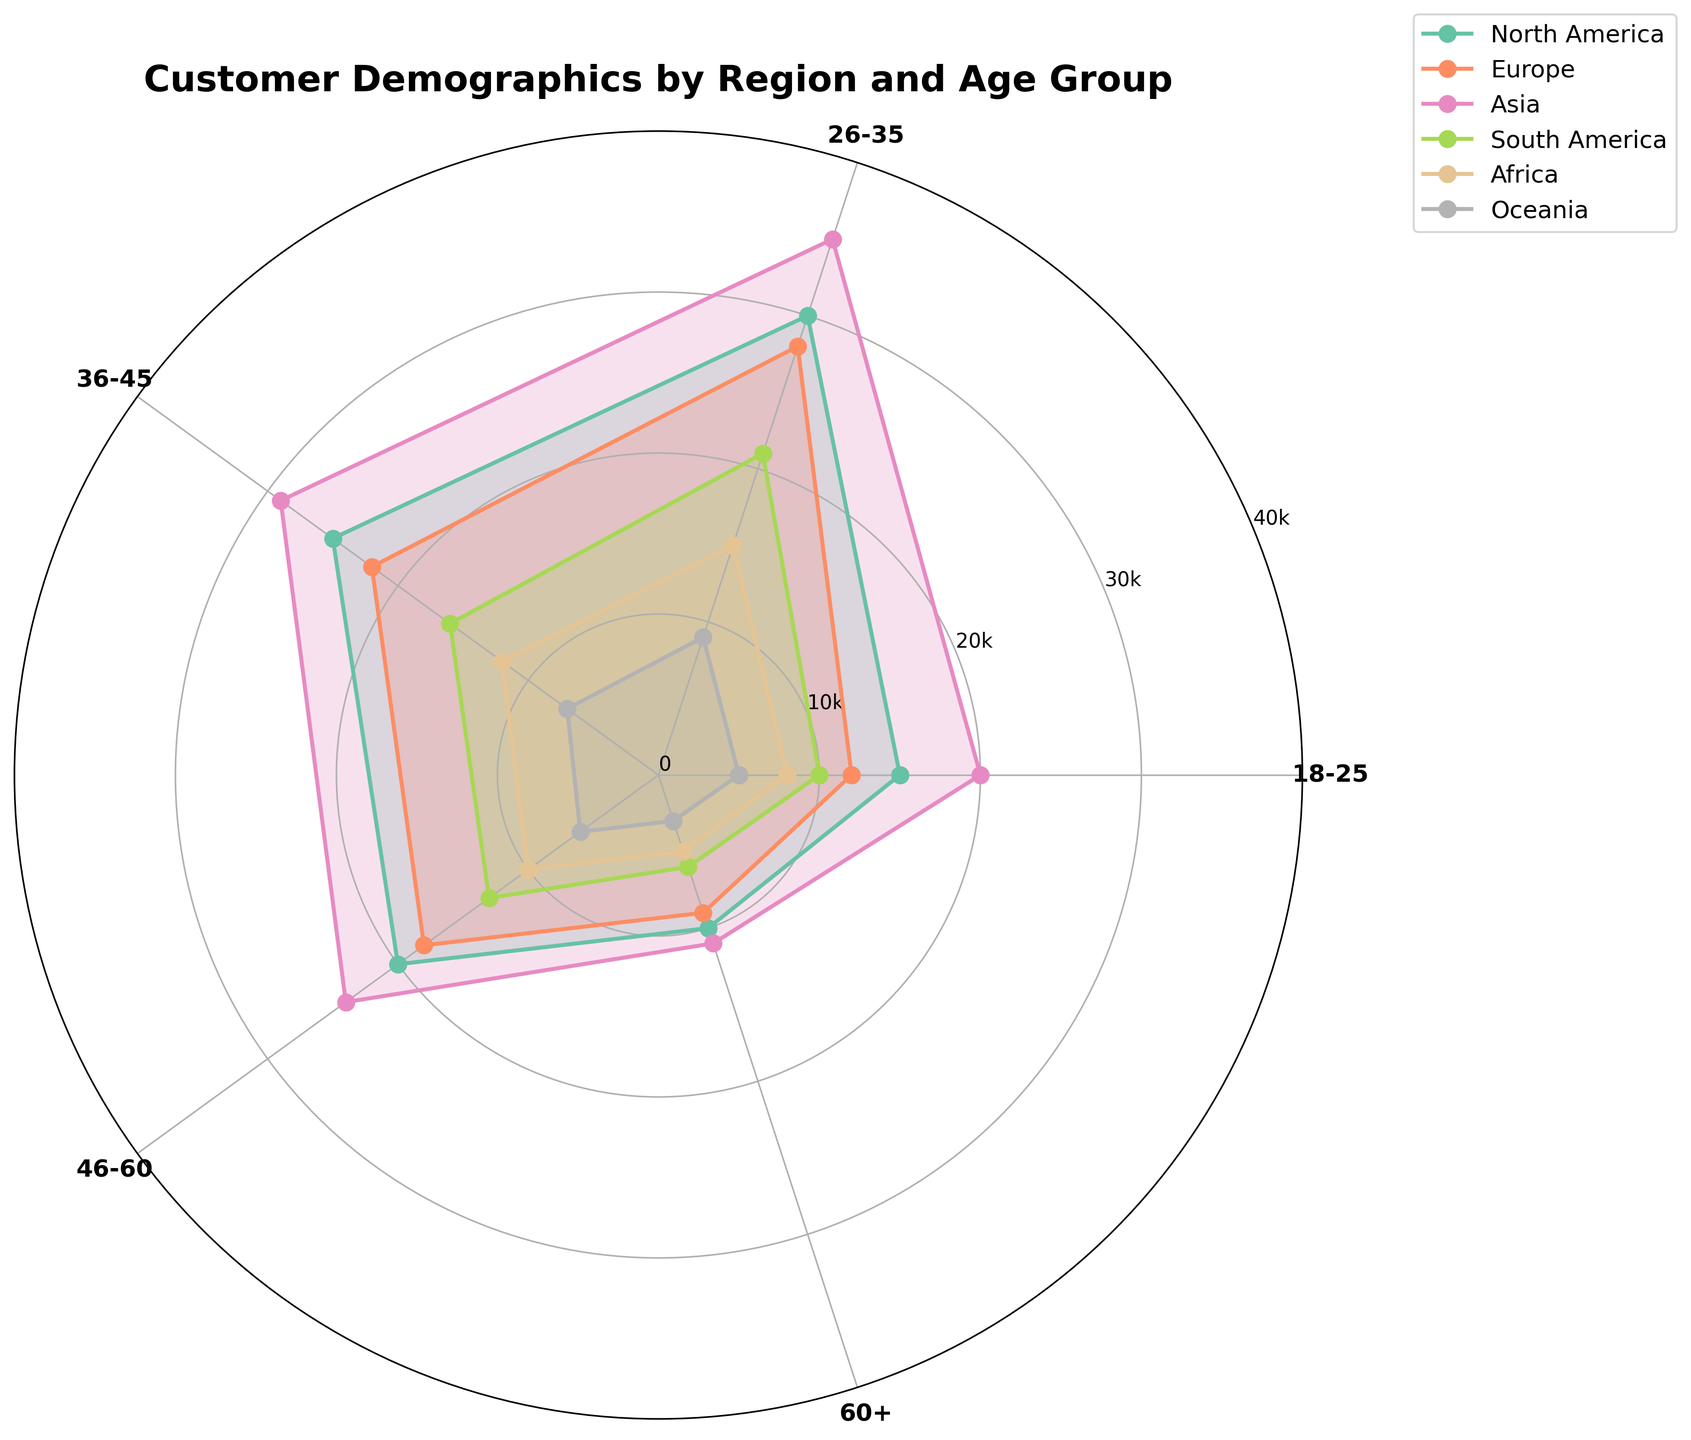What's the title of the chart? The title of the chart is prominently displayed at the top center of the figure as part of its visual elements.
Answer: Customer Demographics by Region and Age Group How many age groups are represented in the chart? To find the number of age groups, count the distinct segments on the x-axis around the polar chart.
Answer: 5 Which region has the highest number of customers in the 26-35 age group? Identify which line segment (representing a region) extends farthest in the segment labeled '26-35'.
Answer: Asia Compare the number of customers in the 46-60 age group between North America and Europe. Which region has more customers? Examine the length of the line segments for North America and Europe in the 46-60 age group section.
Answer: North America What is the combined number of customers for the 18-25 and 60+ age groups in Africa? Sum the lengths of line segments representing the number of customers in the 18-25 and 60+ age groups for Africa.
Answer: 13,000 Which age group in South America has the least number of customers? Find the shortest line segment for South America among the age groups.
Answer: 60+ What is the average number of customers in the 36-45 age group across all regions? Sum the number of customers in the 36-45 age group for all regions and then divide by the number of regions.
Answer: (25000+22000+29000+16000+12000+7000)/6 = 18500 Which region shows the most balanced distribution of customers across all age groups? Look for the region where the line segments are relatively equal in length for all age group segments.
Answer: Europe What is the difference in the number of customers between the 18-25 and 60+ age groups in Oceania? Subtract the number of customers in the 60+ group from that in the 18-25 group for Oceania.
Answer: 2000 Identify the region with the highest total number of customers across all age groups. Sum the number of customers for each age group by region and identify the region with the highest total.
Answer: Asia 